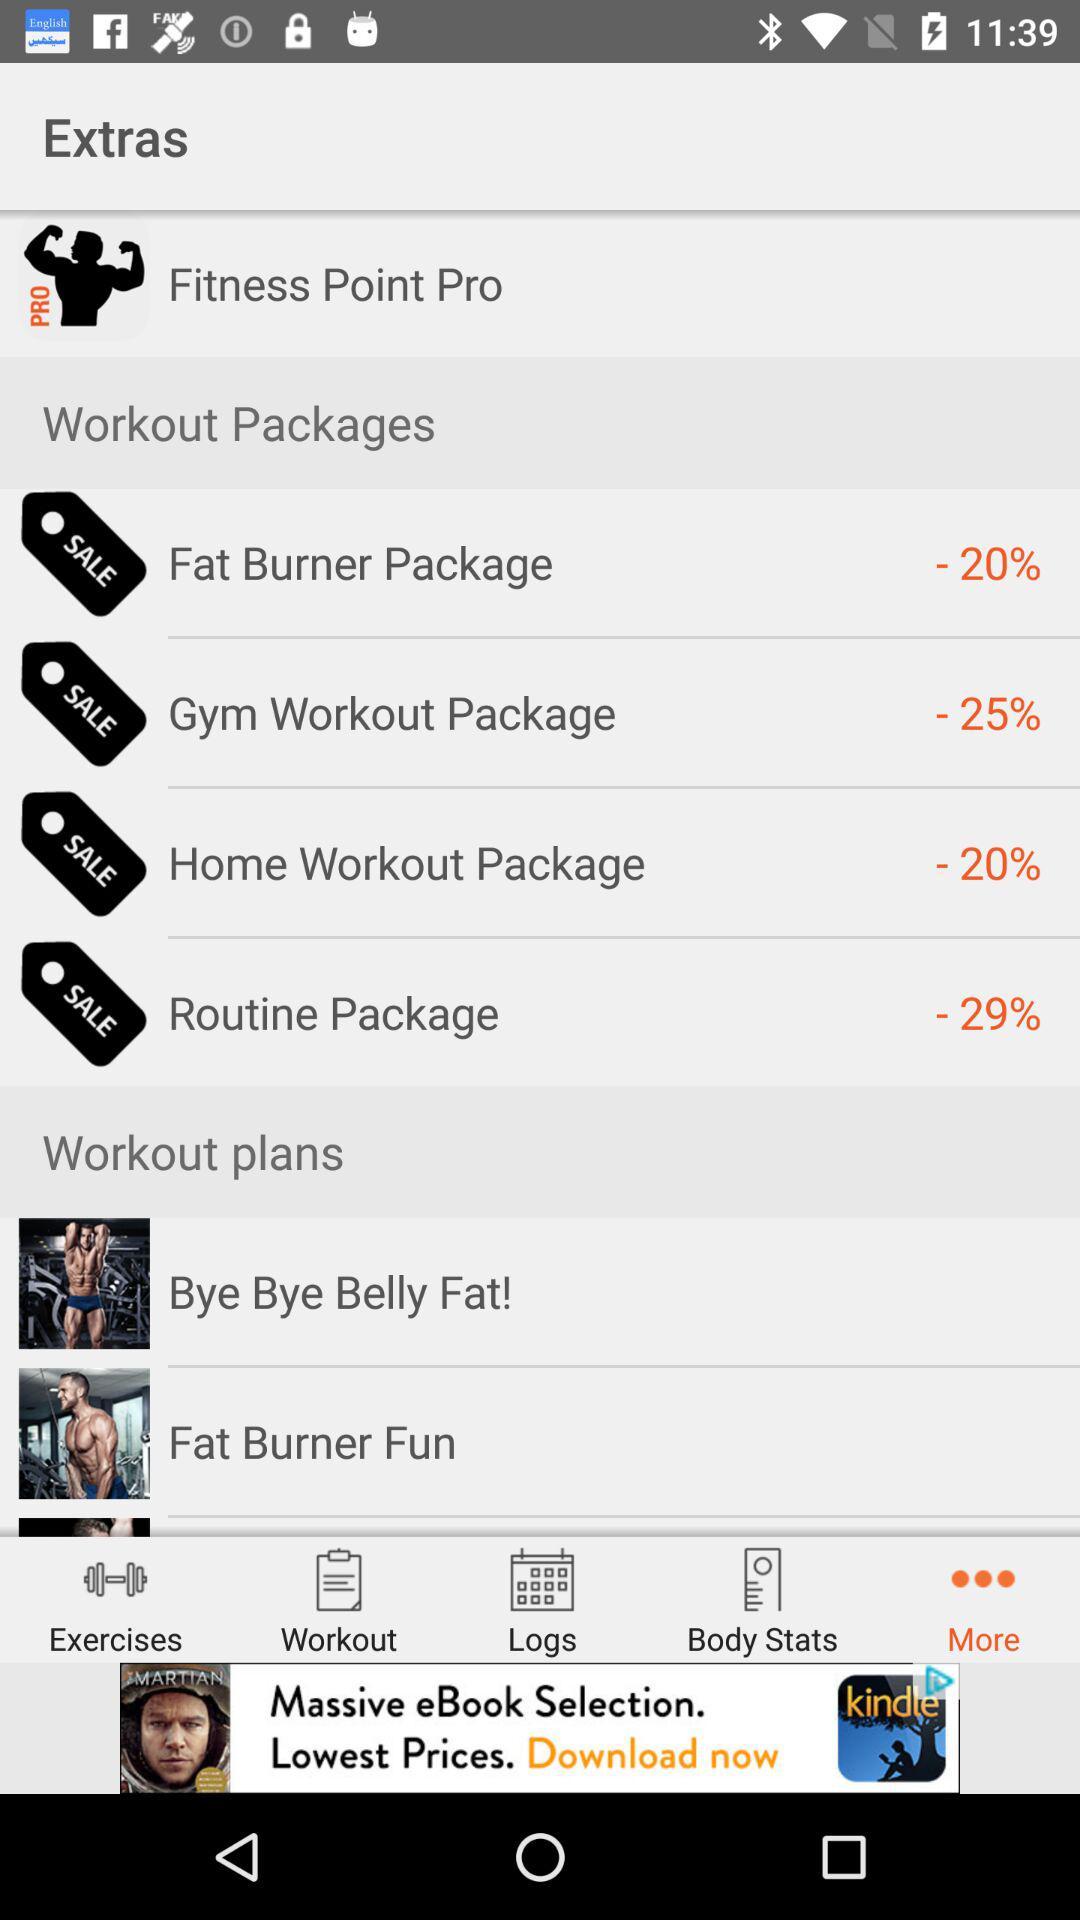What is the discount on "Fat Burner Package"? The discount is -20%. 